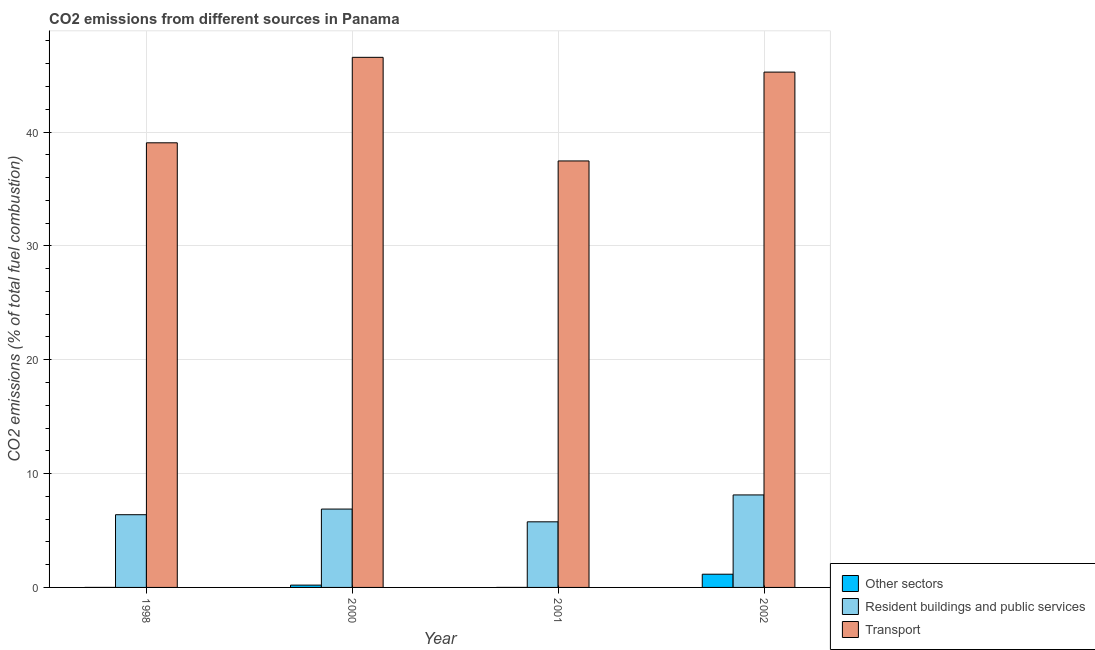How many groups of bars are there?
Provide a succinct answer. 4. Are the number of bars per tick equal to the number of legend labels?
Ensure brevity in your answer.  No. Are the number of bars on each tick of the X-axis equal?
Give a very brief answer. No. How many bars are there on the 1st tick from the left?
Your answer should be very brief. 2. How many bars are there on the 4th tick from the right?
Provide a short and direct response. 2. What is the percentage of co2 emissions from resident buildings and public services in 2001?
Provide a succinct answer. 5.76. Across all years, what is the maximum percentage of co2 emissions from transport?
Provide a short and direct response. 46.56. Across all years, what is the minimum percentage of co2 emissions from resident buildings and public services?
Offer a terse response. 5.76. In which year was the percentage of co2 emissions from resident buildings and public services maximum?
Keep it short and to the point. 2002. What is the total percentage of co2 emissions from resident buildings and public services in the graph?
Give a very brief answer. 27.16. What is the difference between the percentage of co2 emissions from transport in 2000 and that in 2002?
Make the answer very short. 1.3. What is the difference between the percentage of co2 emissions from resident buildings and public services in 2001 and the percentage of co2 emissions from transport in 1998?
Give a very brief answer. -0.62. What is the average percentage of co2 emissions from transport per year?
Your answer should be very brief. 42.08. In the year 2001, what is the difference between the percentage of co2 emissions from transport and percentage of co2 emissions from other sectors?
Your response must be concise. 0. In how many years, is the percentage of co2 emissions from transport greater than 22 %?
Your answer should be compact. 4. What is the ratio of the percentage of co2 emissions from resident buildings and public services in 1998 to that in 2002?
Your answer should be very brief. 0.79. What is the difference between the highest and the second highest percentage of co2 emissions from transport?
Offer a terse response. 1.3. What is the difference between the highest and the lowest percentage of co2 emissions from transport?
Give a very brief answer. 9.1. How many bars are there?
Keep it short and to the point. 11. Are all the bars in the graph horizontal?
Your response must be concise. No. How many years are there in the graph?
Make the answer very short. 4. Does the graph contain any zero values?
Give a very brief answer. Yes. Where does the legend appear in the graph?
Your answer should be compact. Bottom right. How many legend labels are there?
Offer a terse response. 3. What is the title of the graph?
Your answer should be compact. CO2 emissions from different sources in Panama. What is the label or title of the X-axis?
Ensure brevity in your answer.  Year. What is the label or title of the Y-axis?
Offer a very short reply. CO2 emissions (% of total fuel combustion). What is the CO2 emissions (% of total fuel combustion) of Other sectors in 1998?
Provide a short and direct response. 0. What is the CO2 emissions (% of total fuel combustion) in Resident buildings and public services in 1998?
Give a very brief answer. 6.39. What is the CO2 emissions (% of total fuel combustion) of Transport in 1998?
Give a very brief answer. 39.05. What is the CO2 emissions (% of total fuel combustion) of Other sectors in 2000?
Give a very brief answer. 0.2. What is the CO2 emissions (% of total fuel combustion) of Resident buildings and public services in 2000?
Offer a terse response. 6.88. What is the CO2 emissions (% of total fuel combustion) in Transport in 2000?
Your answer should be very brief. 46.56. What is the CO2 emissions (% of total fuel combustion) in Other sectors in 2001?
Your response must be concise. 4.70433485010659e-16. What is the CO2 emissions (% of total fuel combustion) of Resident buildings and public services in 2001?
Keep it short and to the point. 5.76. What is the CO2 emissions (% of total fuel combustion) in Transport in 2001?
Provide a short and direct response. 37.46. What is the CO2 emissions (% of total fuel combustion) in Other sectors in 2002?
Make the answer very short. 1.16. What is the CO2 emissions (% of total fuel combustion) of Resident buildings and public services in 2002?
Offer a terse response. 8.12. What is the CO2 emissions (% of total fuel combustion) of Transport in 2002?
Provide a succinct answer. 45.26. Across all years, what is the maximum CO2 emissions (% of total fuel combustion) in Other sectors?
Your response must be concise. 1.16. Across all years, what is the maximum CO2 emissions (% of total fuel combustion) in Resident buildings and public services?
Provide a short and direct response. 8.12. Across all years, what is the maximum CO2 emissions (% of total fuel combustion) in Transport?
Provide a short and direct response. 46.56. Across all years, what is the minimum CO2 emissions (% of total fuel combustion) in Other sectors?
Offer a very short reply. 0. Across all years, what is the minimum CO2 emissions (% of total fuel combustion) of Resident buildings and public services?
Provide a short and direct response. 5.76. Across all years, what is the minimum CO2 emissions (% of total fuel combustion) in Transport?
Offer a very short reply. 37.46. What is the total CO2 emissions (% of total fuel combustion) in Other sectors in the graph?
Offer a very short reply. 1.36. What is the total CO2 emissions (% of total fuel combustion) in Resident buildings and public services in the graph?
Offer a terse response. 27.16. What is the total CO2 emissions (% of total fuel combustion) of Transport in the graph?
Offer a very short reply. 168.33. What is the difference between the CO2 emissions (% of total fuel combustion) of Resident buildings and public services in 1998 and that in 2000?
Your response must be concise. -0.5. What is the difference between the CO2 emissions (% of total fuel combustion) of Transport in 1998 and that in 2000?
Provide a short and direct response. -7.51. What is the difference between the CO2 emissions (% of total fuel combustion) in Resident buildings and public services in 1998 and that in 2001?
Ensure brevity in your answer.  0.62. What is the difference between the CO2 emissions (% of total fuel combustion) of Transport in 1998 and that in 2001?
Your answer should be very brief. 1.59. What is the difference between the CO2 emissions (% of total fuel combustion) in Resident buildings and public services in 1998 and that in 2002?
Make the answer very short. -1.74. What is the difference between the CO2 emissions (% of total fuel combustion) of Transport in 1998 and that in 2002?
Your answer should be compact. -6.21. What is the difference between the CO2 emissions (% of total fuel combustion) of Other sectors in 2000 and that in 2001?
Your response must be concise. 0.2. What is the difference between the CO2 emissions (% of total fuel combustion) of Resident buildings and public services in 2000 and that in 2001?
Your answer should be very brief. 1.12. What is the difference between the CO2 emissions (% of total fuel combustion) in Transport in 2000 and that in 2001?
Ensure brevity in your answer.  9.1. What is the difference between the CO2 emissions (% of total fuel combustion) in Other sectors in 2000 and that in 2002?
Your response must be concise. -0.96. What is the difference between the CO2 emissions (% of total fuel combustion) in Resident buildings and public services in 2000 and that in 2002?
Offer a terse response. -1.24. What is the difference between the CO2 emissions (% of total fuel combustion) in Transport in 2000 and that in 2002?
Provide a succinct answer. 1.3. What is the difference between the CO2 emissions (% of total fuel combustion) of Other sectors in 2001 and that in 2002?
Provide a short and direct response. -1.16. What is the difference between the CO2 emissions (% of total fuel combustion) in Resident buildings and public services in 2001 and that in 2002?
Ensure brevity in your answer.  -2.36. What is the difference between the CO2 emissions (% of total fuel combustion) in Transport in 2001 and that in 2002?
Your response must be concise. -7.8. What is the difference between the CO2 emissions (% of total fuel combustion) in Resident buildings and public services in 1998 and the CO2 emissions (% of total fuel combustion) in Transport in 2000?
Keep it short and to the point. -40.17. What is the difference between the CO2 emissions (% of total fuel combustion) in Resident buildings and public services in 1998 and the CO2 emissions (% of total fuel combustion) in Transport in 2001?
Your answer should be very brief. -31.07. What is the difference between the CO2 emissions (% of total fuel combustion) in Resident buildings and public services in 1998 and the CO2 emissions (% of total fuel combustion) in Transport in 2002?
Keep it short and to the point. -38.87. What is the difference between the CO2 emissions (% of total fuel combustion) in Other sectors in 2000 and the CO2 emissions (% of total fuel combustion) in Resident buildings and public services in 2001?
Give a very brief answer. -5.56. What is the difference between the CO2 emissions (% of total fuel combustion) of Other sectors in 2000 and the CO2 emissions (% of total fuel combustion) of Transport in 2001?
Give a very brief answer. -37.26. What is the difference between the CO2 emissions (% of total fuel combustion) of Resident buildings and public services in 2000 and the CO2 emissions (% of total fuel combustion) of Transport in 2001?
Keep it short and to the point. -30.57. What is the difference between the CO2 emissions (% of total fuel combustion) in Other sectors in 2000 and the CO2 emissions (% of total fuel combustion) in Resident buildings and public services in 2002?
Provide a short and direct response. -7.92. What is the difference between the CO2 emissions (% of total fuel combustion) in Other sectors in 2000 and the CO2 emissions (% of total fuel combustion) in Transport in 2002?
Provide a short and direct response. -45.06. What is the difference between the CO2 emissions (% of total fuel combustion) of Resident buildings and public services in 2000 and the CO2 emissions (% of total fuel combustion) of Transport in 2002?
Your answer should be compact. -38.38. What is the difference between the CO2 emissions (% of total fuel combustion) of Other sectors in 2001 and the CO2 emissions (% of total fuel combustion) of Resident buildings and public services in 2002?
Your answer should be very brief. -8.12. What is the difference between the CO2 emissions (% of total fuel combustion) of Other sectors in 2001 and the CO2 emissions (% of total fuel combustion) of Transport in 2002?
Keep it short and to the point. -45.26. What is the difference between the CO2 emissions (% of total fuel combustion) in Resident buildings and public services in 2001 and the CO2 emissions (% of total fuel combustion) in Transport in 2002?
Offer a terse response. -39.5. What is the average CO2 emissions (% of total fuel combustion) in Other sectors per year?
Keep it short and to the point. 0.34. What is the average CO2 emissions (% of total fuel combustion) in Resident buildings and public services per year?
Keep it short and to the point. 6.79. What is the average CO2 emissions (% of total fuel combustion) of Transport per year?
Keep it short and to the point. 42.08. In the year 1998, what is the difference between the CO2 emissions (% of total fuel combustion) of Resident buildings and public services and CO2 emissions (% of total fuel combustion) of Transport?
Offer a very short reply. -32.66. In the year 2000, what is the difference between the CO2 emissions (% of total fuel combustion) of Other sectors and CO2 emissions (% of total fuel combustion) of Resident buildings and public services?
Your answer should be very brief. -6.68. In the year 2000, what is the difference between the CO2 emissions (% of total fuel combustion) in Other sectors and CO2 emissions (% of total fuel combustion) in Transport?
Your answer should be very brief. -46.36. In the year 2000, what is the difference between the CO2 emissions (% of total fuel combustion) in Resident buildings and public services and CO2 emissions (% of total fuel combustion) in Transport?
Give a very brief answer. -39.68. In the year 2001, what is the difference between the CO2 emissions (% of total fuel combustion) of Other sectors and CO2 emissions (% of total fuel combustion) of Resident buildings and public services?
Keep it short and to the point. -5.76. In the year 2001, what is the difference between the CO2 emissions (% of total fuel combustion) in Other sectors and CO2 emissions (% of total fuel combustion) in Transport?
Your answer should be very brief. -37.46. In the year 2001, what is the difference between the CO2 emissions (% of total fuel combustion) of Resident buildings and public services and CO2 emissions (% of total fuel combustion) of Transport?
Give a very brief answer. -31.69. In the year 2002, what is the difference between the CO2 emissions (% of total fuel combustion) in Other sectors and CO2 emissions (% of total fuel combustion) in Resident buildings and public services?
Ensure brevity in your answer.  -6.96. In the year 2002, what is the difference between the CO2 emissions (% of total fuel combustion) of Other sectors and CO2 emissions (% of total fuel combustion) of Transport?
Your answer should be very brief. -44.1. In the year 2002, what is the difference between the CO2 emissions (% of total fuel combustion) in Resident buildings and public services and CO2 emissions (% of total fuel combustion) in Transport?
Your answer should be compact. -37.14. What is the ratio of the CO2 emissions (% of total fuel combustion) in Resident buildings and public services in 1998 to that in 2000?
Provide a succinct answer. 0.93. What is the ratio of the CO2 emissions (% of total fuel combustion) in Transport in 1998 to that in 2000?
Keep it short and to the point. 0.84. What is the ratio of the CO2 emissions (% of total fuel combustion) of Resident buildings and public services in 1998 to that in 2001?
Offer a terse response. 1.11. What is the ratio of the CO2 emissions (% of total fuel combustion) of Transport in 1998 to that in 2001?
Make the answer very short. 1.04. What is the ratio of the CO2 emissions (% of total fuel combustion) in Resident buildings and public services in 1998 to that in 2002?
Keep it short and to the point. 0.79. What is the ratio of the CO2 emissions (% of total fuel combustion) of Transport in 1998 to that in 2002?
Provide a succinct answer. 0.86. What is the ratio of the CO2 emissions (% of total fuel combustion) in Other sectors in 2000 to that in 2001?
Keep it short and to the point. 4.30e+14. What is the ratio of the CO2 emissions (% of total fuel combustion) in Resident buildings and public services in 2000 to that in 2001?
Give a very brief answer. 1.19. What is the ratio of the CO2 emissions (% of total fuel combustion) of Transport in 2000 to that in 2001?
Ensure brevity in your answer.  1.24. What is the ratio of the CO2 emissions (% of total fuel combustion) of Other sectors in 2000 to that in 2002?
Keep it short and to the point. 0.17. What is the ratio of the CO2 emissions (% of total fuel combustion) in Resident buildings and public services in 2000 to that in 2002?
Your answer should be compact. 0.85. What is the ratio of the CO2 emissions (% of total fuel combustion) of Transport in 2000 to that in 2002?
Your response must be concise. 1.03. What is the ratio of the CO2 emissions (% of total fuel combustion) of Other sectors in 2001 to that in 2002?
Ensure brevity in your answer.  0. What is the ratio of the CO2 emissions (% of total fuel combustion) of Resident buildings and public services in 2001 to that in 2002?
Provide a succinct answer. 0.71. What is the ratio of the CO2 emissions (% of total fuel combustion) of Transport in 2001 to that in 2002?
Provide a short and direct response. 0.83. What is the difference between the highest and the second highest CO2 emissions (% of total fuel combustion) in Other sectors?
Your response must be concise. 0.96. What is the difference between the highest and the second highest CO2 emissions (% of total fuel combustion) in Resident buildings and public services?
Offer a terse response. 1.24. What is the difference between the highest and the second highest CO2 emissions (% of total fuel combustion) of Transport?
Offer a very short reply. 1.3. What is the difference between the highest and the lowest CO2 emissions (% of total fuel combustion) of Other sectors?
Your response must be concise. 1.16. What is the difference between the highest and the lowest CO2 emissions (% of total fuel combustion) of Resident buildings and public services?
Your answer should be compact. 2.36. What is the difference between the highest and the lowest CO2 emissions (% of total fuel combustion) in Transport?
Keep it short and to the point. 9.1. 